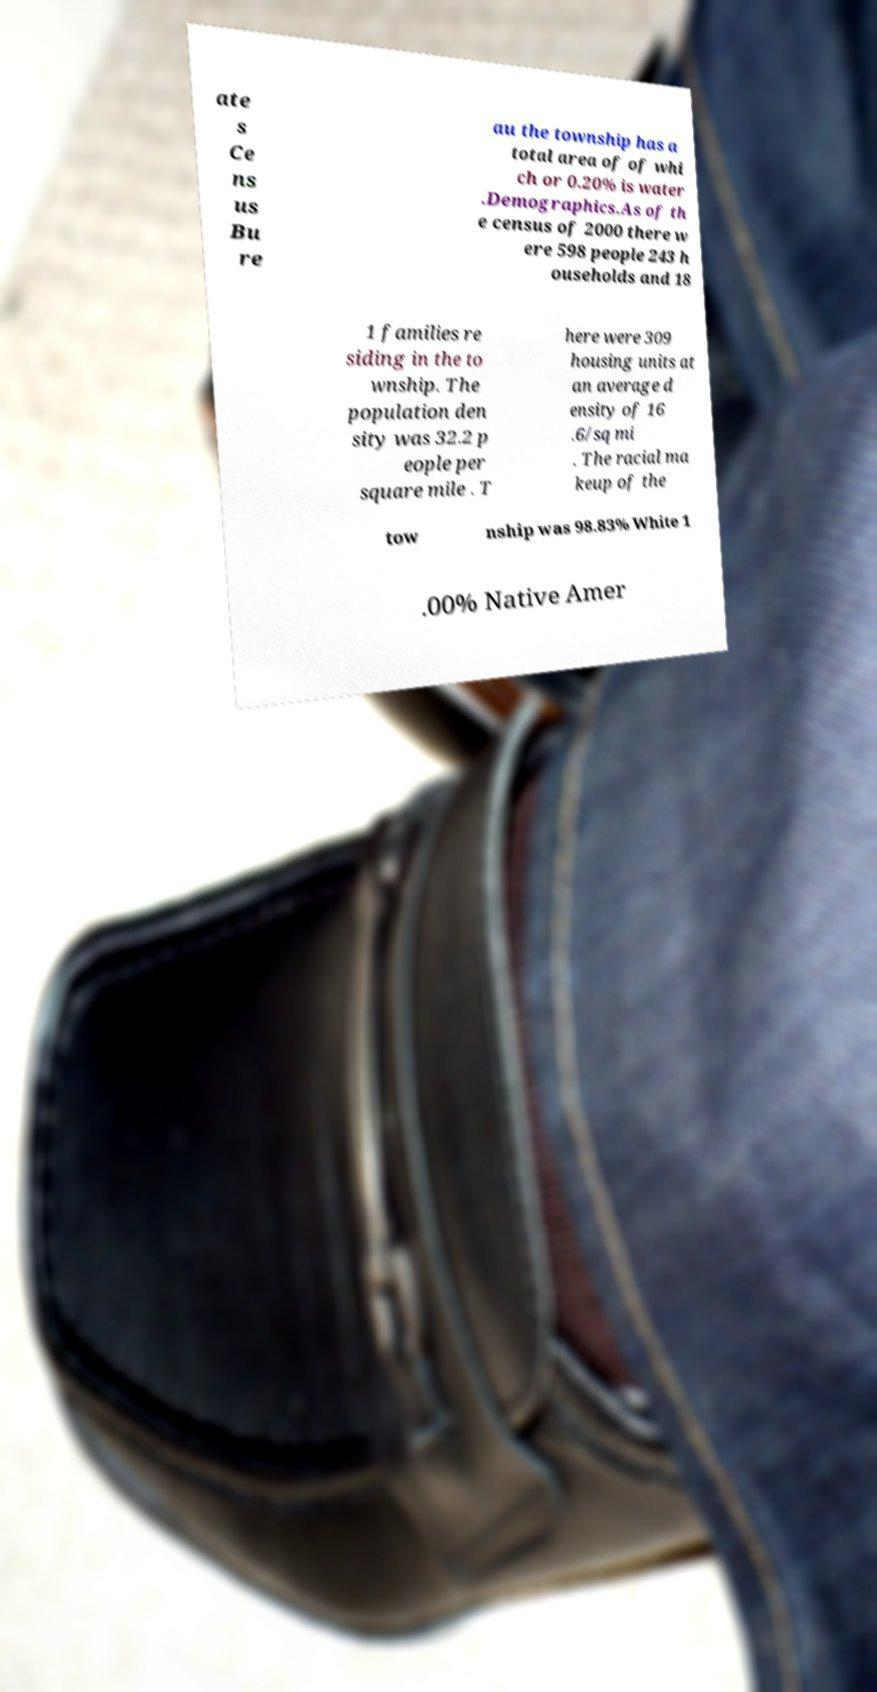Please read and relay the text visible in this image. What does it say? ate s Ce ns us Bu re au the township has a total area of of whi ch or 0.20% is water .Demographics.As of th e census of 2000 there w ere 598 people 243 h ouseholds and 18 1 families re siding in the to wnship. The population den sity was 32.2 p eople per square mile . T here were 309 housing units at an average d ensity of 16 .6/sq mi . The racial ma keup of the tow nship was 98.83% White 1 .00% Native Amer 